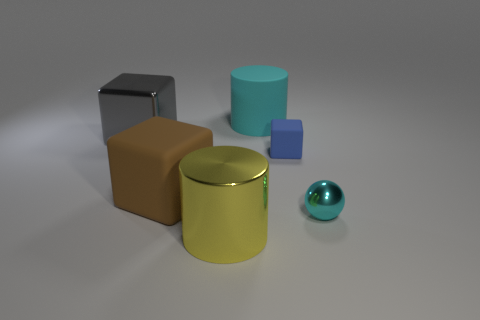Is the cylinder to the left of the large cyan rubber cylinder made of the same material as the big cyan cylinder?
Ensure brevity in your answer.  No. Are there any tiny green metallic cylinders?
Your response must be concise. No. How big is the thing that is both in front of the gray metal thing and behind the brown rubber thing?
Your answer should be compact. Small. Are there more tiny shiny balls in front of the small matte block than metal spheres on the left side of the big gray thing?
Keep it short and to the point. Yes. What is the size of the metallic object that is the same color as the rubber cylinder?
Ensure brevity in your answer.  Small. What color is the small matte block?
Your answer should be very brief. Blue. What color is the big thing that is behind the large brown rubber block and on the left side of the large yellow shiny cylinder?
Your answer should be compact. Gray. The large cube that is right of the metal thing that is behind the big rubber object that is to the left of the big yellow cylinder is what color?
Provide a short and direct response. Brown. What is the color of the shiny ball that is the same size as the blue rubber object?
Your answer should be very brief. Cyan. There is a cyan matte thing that is on the right side of the cylinder in front of the small thing that is in front of the brown matte object; what shape is it?
Your answer should be very brief. Cylinder. 